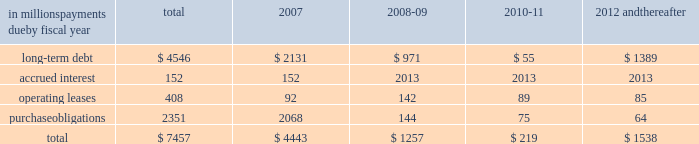Guarantees to third parties .
We have , however , issued guar- antees and comfort letters of $ 171 million for the debt and other obligations of unconsolidated affiliates , primarily for cpw .
In addition , off-balance sheet arrangements are gener- ally limited to the future payments under noncancelable operating leases , which totaled $ 408 million at may 28 , at may 28 , 2006 , we had invested in four variable interest entities ( vies ) .
We are the primary beneficiary ( pb ) of general mills capital , inc .
( gm capital ) , a subsidiary that we consolidate as set forth in note eight to the consoli- dated financial statements appearing on pages 43 and 44 in item eight of this report .
We also have an interest in a contract manufacturer at our former facility in geneva , illi- nois .
Even though we are the pb , we have not consolidated this entity because it is not material to our results of oper- ations , financial condition , or liquidity at may 28 , 2006 .
This entity had property and equipment of $ 50 million and long-term debt of $ 50 million at may 28 , 2006 .
We are not the pb of the remaining two vies .
Our maximum exposure to loss from these vies is limited to the $ 150 million minority interest in gm capital , the contract manufactur- er 2019s debt and our $ 6 million of equity investments in the two remaining vies .
The table summarizes our future estimated cash payments under existing contractual obligations , including payments due by period .
The majority of the purchase obligations represent commitments for raw mate- rial and packaging to be utilized in the normal course of business and for consumer-directed marketing commit- ments that support our brands .
The net fair value of our interest rate and equity swaps was $ 159 million at may 28 , 2006 , based on market values as of that date .
Future changes in market values will impact the amount of cash ultimately paid or received to settle those instruments in the future .
Other long-term obligations primarily consist of income taxes , accrued compensation and benefits , and miscella- neous liabilities .
We are unable to estimate the timing of the payments for these items .
We do not have significant statutory or contractual funding requirements for our defined-benefit retirement and other postretirement benefit plans .
Further information on these plans , including our expected contributions for fiscal 2007 , is set forth in note thirteen to the consolidated financial statements appearing on pages 47 through 50 in item eight of this report .
In millions , payments due by fiscal year total 2007 2008-09 2010-11 2012 and thereafter .
Significant accounting estimates for a complete description of our significant accounting policies , please see note one to the consolidated financial statements appearing on pages 35 through 37 in item eight of this report .
Our significant accounting estimates are those that have meaningful impact on the reporting of our financial condition and results of operations .
These poli- cies include our accounting for trade and consumer promotion activities ; goodwill and other intangible asset impairments ; income taxes ; and pension and other postretirement benefits .
Trade and consumer promotion activities we report sales net of certain coupon and trade promotion costs .
The consumer coupon costs recorded as a reduction of sales are based on the estimated redemption value of those coupons , as determined by historical patterns of coupon redemption and consideration of current market conditions such as competitive activity in those product categories .
The trade promotion costs include payments to customers to perform merchandising activities on our behalf , such as advertising or in-store displays , discounts to our list prices to lower retail shelf prices , and payments to gain distribution of new products .
The cost of these activi- ties is recognized as the related revenue is recorded , which generally precedes the actual cash expenditure .
The recog- nition of these costs requires estimation of customer participation and performance levels .
These estimates are made based on the quantity of customer sales , the timing and forecasted costs of promotional activities , and other factors .
Differences between estimated expenses and actual costs are normally insignificant and are recognized as a change in management estimate in a subsequent period .
Our accrued trade and consumer promotion liability was $ 339 million as of may 28 , 2006 , and $ 283 million as of may 29 , 2005 .
Our unit volume in the last week of each quarter is consis- tently higher than the average for the preceding weeks of the quarter .
In comparison to the average daily shipments in the first 12 weeks of a quarter , the final week of each quarter has approximately two to four days 2019 worth of incre- mental shipments ( based on a five-day week ) , reflecting increased promotional activity at the end of the quarter .
This increased activity includes promotions to assure that our customers have sufficient inventory on hand to support major marketing events or increased seasonal demand early in the next quarter , as well as promotions intended to help achieve interim unit volume targets .
If , due to quarter-end promotions or other reasons , our customers purchase more product in any reporting period than end-consumer demand will require in future periods , our sales level in future reporting periods could be adversely affected. .
What was the percent of the total expected contributions for fiscal 2007 that was long-term debt? 
Computations: (2131 / 4546)
Answer: 0.46876. 